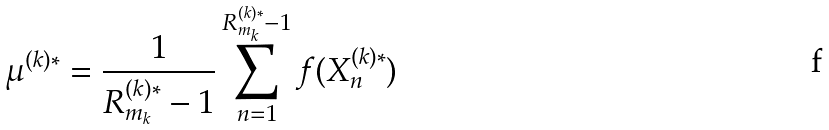<formula> <loc_0><loc_0><loc_500><loc_500>\mu ^ { ( k ) * } = \frac { 1 } { R ^ { ( k ) * } _ { m _ { k } } - 1 } \sum ^ { R ^ { ( k ) * } _ { m _ { k } } - 1 } _ { n = 1 } f ( X ^ { ( k ) * } _ { n } )</formula> 